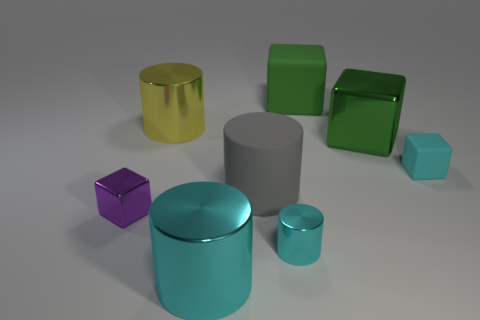Subtract all gray blocks. How many cyan cylinders are left? 2 Subtract all gray cylinders. How many cylinders are left? 3 Subtract 1 blocks. How many blocks are left? 3 Subtract all cyan blocks. How many blocks are left? 3 Add 2 blue blocks. How many objects exist? 10 Subtract all yellow blocks. Subtract all red cylinders. How many blocks are left? 4 Add 1 cylinders. How many cylinders are left? 5 Add 4 yellow things. How many yellow things exist? 5 Subtract 0 gray cubes. How many objects are left? 8 Subtract all tiny gray cylinders. Subtract all big green objects. How many objects are left? 6 